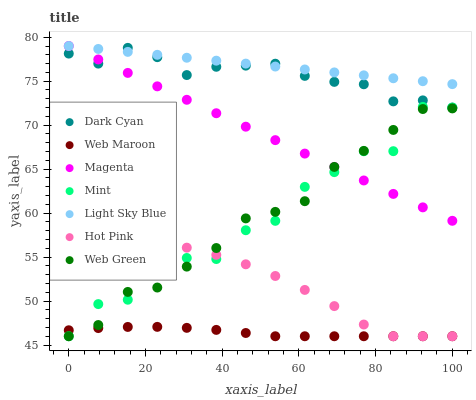Does Web Maroon have the minimum area under the curve?
Answer yes or no. Yes. Does Light Sky Blue have the maximum area under the curve?
Answer yes or no. Yes. Does Web Green have the minimum area under the curve?
Answer yes or no. No. Does Web Green have the maximum area under the curve?
Answer yes or no. No. Is Light Sky Blue the smoothest?
Answer yes or no. Yes. Is Mint the roughest?
Answer yes or no. Yes. Is Web Maroon the smoothest?
Answer yes or no. No. Is Web Maroon the roughest?
Answer yes or no. No. Does Hot Pink have the lowest value?
Answer yes or no. Yes. Does Light Sky Blue have the lowest value?
Answer yes or no. No. Does Magenta have the highest value?
Answer yes or no. Yes. Does Web Green have the highest value?
Answer yes or no. No. Is Mint less than Dark Cyan?
Answer yes or no. Yes. Is Light Sky Blue greater than Hot Pink?
Answer yes or no. Yes. Does Light Sky Blue intersect Dark Cyan?
Answer yes or no. Yes. Is Light Sky Blue less than Dark Cyan?
Answer yes or no. No. Is Light Sky Blue greater than Dark Cyan?
Answer yes or no. No. Does Mint intersect Dark Cyan?
Answer yes or no. No. 